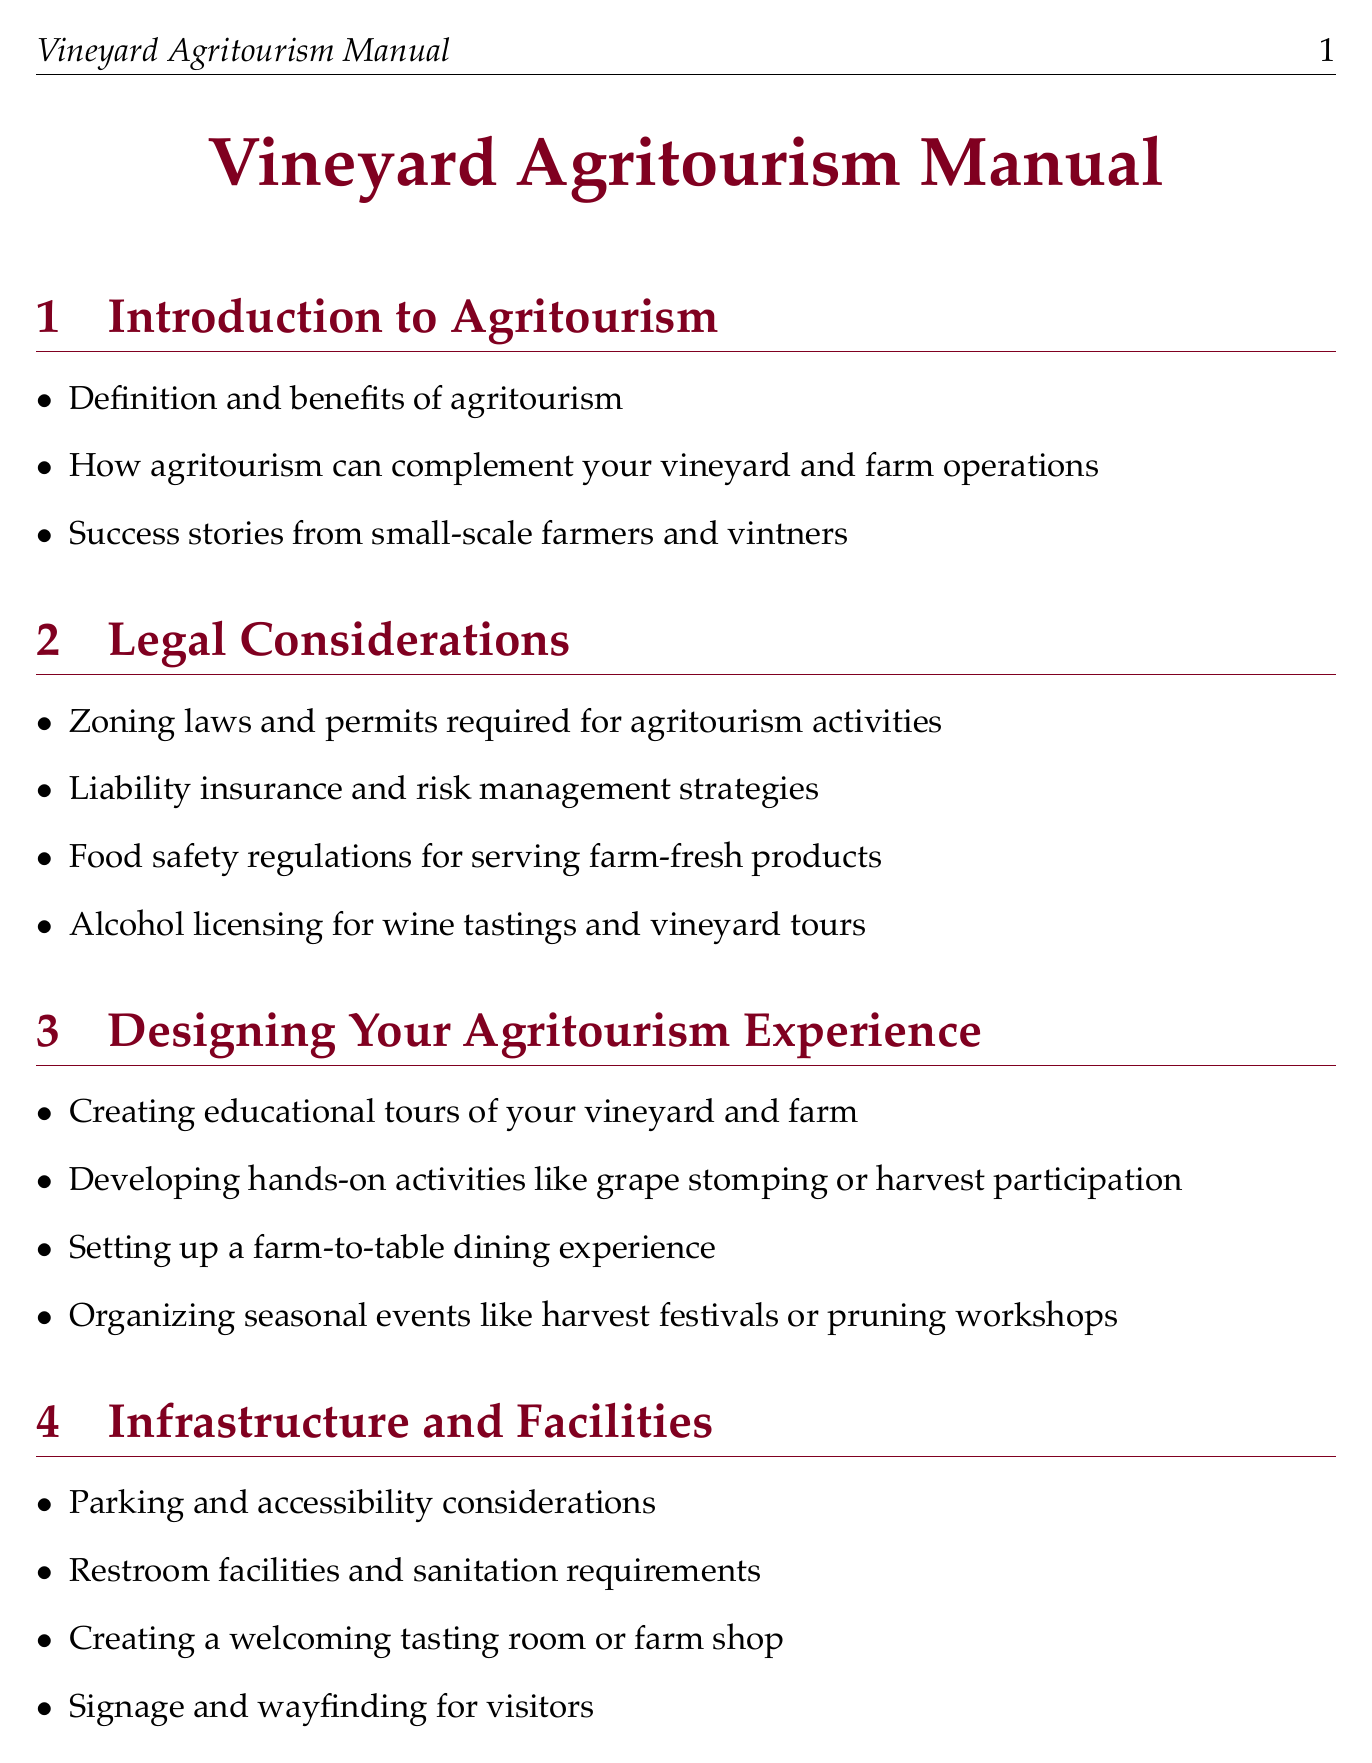What are the benefits of agritourism? The benefits of agritourism include increased revenue, marketing capabilities, and enhancing visitor experiences at the vineyard and farm.
Answer: Increased revenue, marketing capabilities, and enhancing visitor experiences What is needed for alcohol licensing during tours? Alcohol licensing is required for wine tastings and vineyard tours as mentioned in the legal considerations section.
Answer: Wine tastings and vineyard tours What seasonal event is suggested for October? The document lists specific seasonal events that can be organized, including a harvest celebration and grape stomp in October.
Answer: Harvest Celebration and Grape Stomp Which marketing strategy involves social media? The document discusses leveraging social media platforms to promote agritourism offerings effectively.
Answer: Social media platforms How is customer feedback collected? A customer feedback system is developed to understand visitor preferences and improve experiences as outlined in customer service.
Answer: Customer feedback system What is essential for creating a welcoming facility? To create a welcoming tasting room or farm shop, specific infrastructure and facilities must be established, as detailed in the document.
Answer: Tasting room or farm shop How can agritourism success be measured? Key performance indicators for the agritourism program can be tracked to measure success as per the continuous improvement section.
Answer: Key performance indicators What partnership opportunities are available? The document suggests joining local food and wine trails as a means of partnership for agritourism ventures.
Answer: Local food and wine trails What is one case study highlighted in the manual? The manual provides insights into Willamette Valley Vineyards as a case study of successful agritourism implementation.
Answer: Willamette Valley Vineyards 